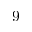Convert formula to latex. <formula><loc_0><loc_0><loc_500><loc_500>9</formula> 